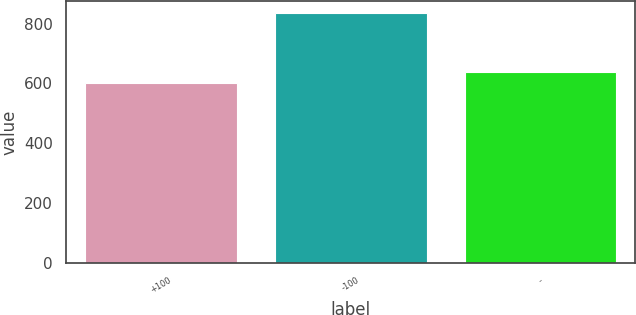<chart> <loc_0><loc_0><loc_500><loc_500><bar_chart><fcel>+100<fcel>-100<fcel>-<nl><fcel>601<fcel>834<fcel>637<nl></chart> 